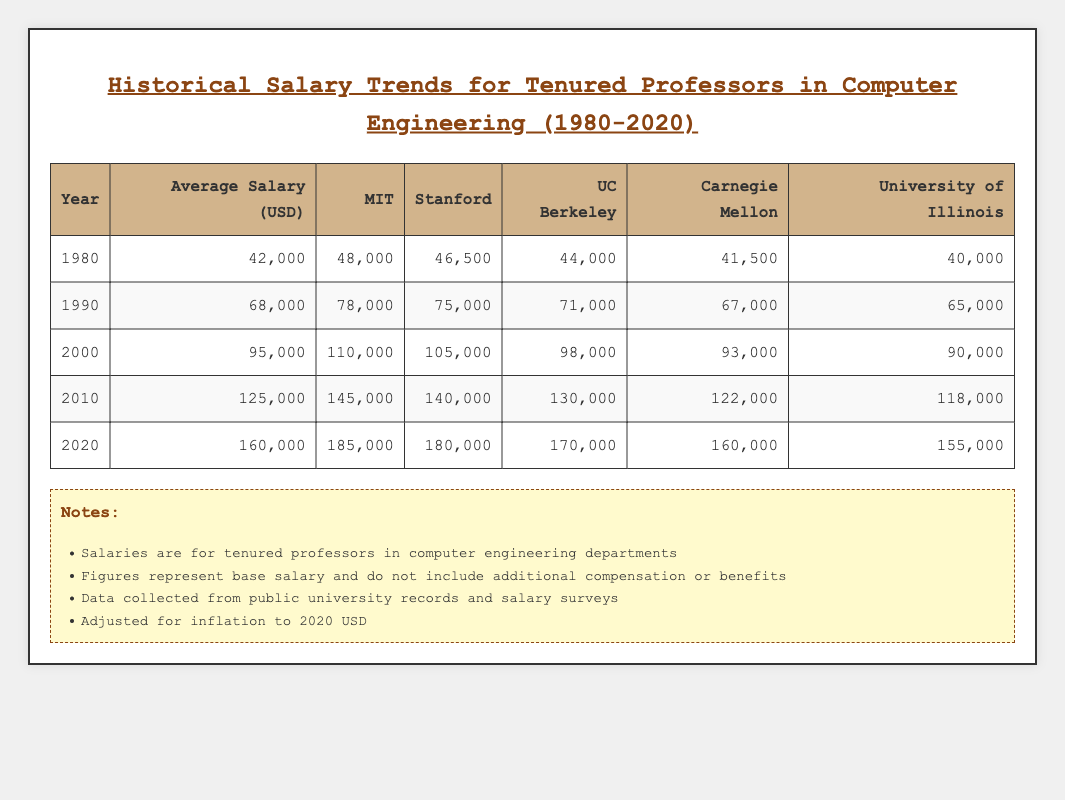What was the average salary for tenured professors in computer engineering in 1990? The table shows that the average salary in 1990 was listed under the "Average Salary (USD)" column, which is 68,000 USD.
Answer: 68,000 Which university had the highest salary in 2000? By looking at the salaries for 2000, MIT has the highest salary listed at 110,000 USD compared to other universities.
Answer: MIT What is the difference in the average salary between 2020 and 1980? The average salary in 2020 was 160,000 USD, and in 1980 it was 42,000 USD. The difference is 160,000 - 42,000 = 118,000 USD.
Answer: 118,000 Did the salary for tenured professors at Stanford increase every decade from 1980 to 2020? By examining the values for Stanford across each decade: 46,500 (1980), 75,000 (1990), 105,000 (2000), 140,000 (2010), and 180,000 (2020), we see that the salary increased each decade.
Answer: Yes What was the average salary for tenured professors in computer engineering across all universities in 2010? The average salaries in 2010 for each university were: MIT (145,000), Stanford (140,000), UC Berkeley (130,000), Carnegie Mellon (122,000), and University of Illinois (118,000). The total salary is 145,000 + 140,000 + 130,000 + 122,000 + 118,000 = 655,000 USD. To find the average, we divide by 5 (the number of universities): 655,000 / 5 = 131,000 USD.
Answer: 131,000 What is the median salary for tenured professors in 1990 and 2020 from the data provided? In 1990, the salaries were as follows: (78,000, 75,000, 71,000, 67,000, 65,000). Arranging these values in order, the median (middle value) is 71,000 USD. In 2020, the salaries were: (185,000, 180,000, 170,000, 160,000, 155,000). Arranging these values, the median is 170,000 USD. Thus, the medians are 71,000 for 1990 and 170,000 for 2020.
Answer: 71,000 and 170,000 Which university had the greatest salary increase from 2000 to 2010? To determine the greatest salary increase, we calculate the difference for each university from 2000 to 2010: MIT (145,000 - 110,000 = 35,000), Stanford (140,000 - 105,000 = 35,000), UC Berkeley (130,000 - 98,000 = 32,000), Carnegie Mellon (122,000 - 93,000 = 29,000), University of Illinois (118,000 - 90,000 = 28,000). The highest increases are 35,000 USD for both MIT and Stanford.
Answer: MIT and Stanford 